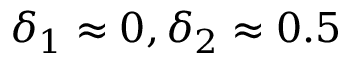Convert formula to latex. <formula><loc_0><loc_0><loc_500><loc_500>\delta _ { 1 } \approx 0 , \delta _ { 2 } \approx 0 . 5</formula> 